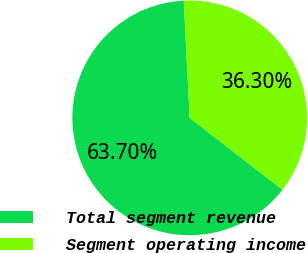Convert chart to OTSL. <chart><loc_0><loc_0><loc_500><loc_500><pie_chart><fcel>Total segment revenue<fcel>Segment operating income<nl><fcel>63.7%<fcel>36.3%<nl></chart> 